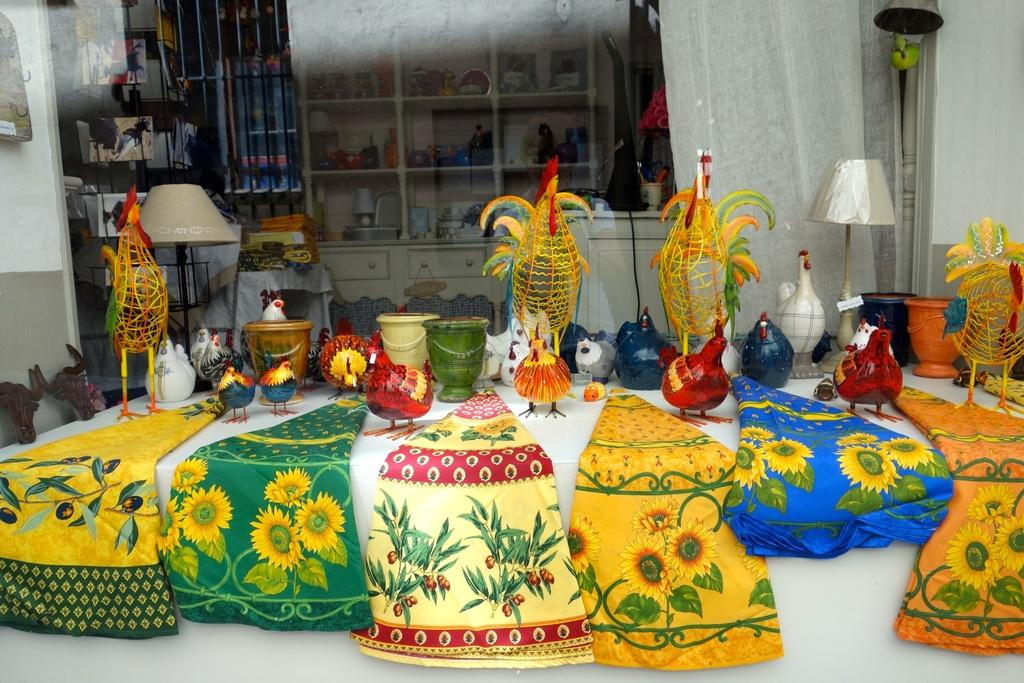What types of objects can be seen in the image? There are many toys of different colors and shapes in the image. Can you describe any other objects in the image besides the toys? Yes, there is a lamp, clothes, a shelf, and a fence in the image. What type of fowl can be seen perched on the shelf in the image? There is no fowl present in the image; the shelf contains toys, clothes, and other items. Can you describe the design of the fence in the image? The provided facts do not mention the design of the fence, only that it is present in the image. 